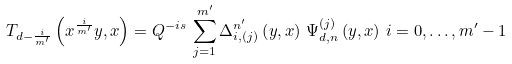Convert formula to latex. <formula><loc_0><loc_0><loc_500><loc_500>T _ { d - \frac { i } { m ^ { \prime } } } \left ( x ^ { \frac { i } { m ^ { \prime } } } y , x \right ) = Q ^ { - i s } \, \sum _ { j = 1 } ^ { m ^ { \prime } } \Delta _ { i , \left ( j \right ) } ^ { n ^ { \prime } } \left ( y , x \right ) \, \Psi _ { d , n } ^ { \left ( j \right ) } \left ( y , x \right ) \, i = 0 , \dots , m ^ { \prime } - 1</formula> 